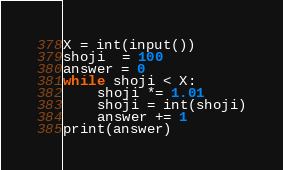Convert code to text. <code><loc_0><loc_0><loc_500><loc_500><_Python_>X = int(input())
shoji  = 100
answer = 0
while shoji < X:
    shoji *= 1.01
    shoji = int(shoji)
    answer += 1
print(answer)
</code> 